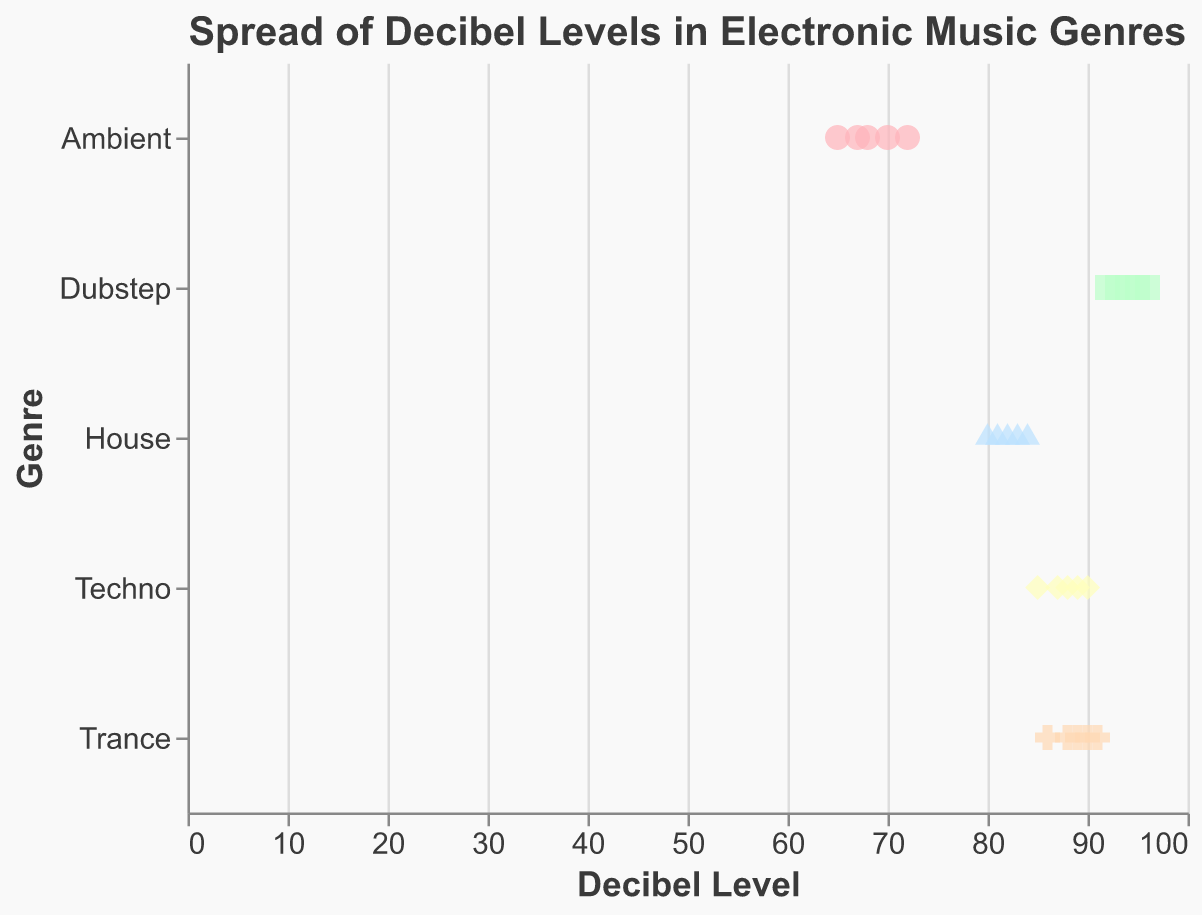What is the genre with the lowest decibel level in the chart? The lowest decibel level shown in the ambient genre is 65. The other genres have higher minimum decibel levels.
Answer: Ambient How many total data points are plotted in the chart? By counting each data point for each genre (Ambient has 5, Techno has 5, House has 5, Trance has 5, Dubstep has 5), we get a total of 25 data points.
Answer: 25 Which genre has the highest decibel level, and what is that level? The highest decibel level is found in the Dubstep genre, with a maximum value of 96.
Answer: Dubstep, 96 What is the range of decibel levels for the House genre? The House genre has decibel levels ranging from 80 to 84. Thus, the range is calculated as 84 - 80 = 4.
Answer: 4 What shapes are used to represent different genres on the plot? The plot uses different shapes to represent genres: circle, square, triangle, diamond, and cross.
Answer: circle, square, triangle, diamond, cross What is the average decibel level of the Techno genre? Sum the decibel levels for Techno (85 + 88 + 90 + 87 + 89) which equals 439. Then, divide by the number of data points (5), so 439 / 5 = 87.8.
Answer: 87.8 How do the average decibel levels of Trance and Dubstep compare? First, calculate the averages: Trance (86 + 89 + 91 + 88 + 90) = 444 / 5 = 88.8, Dubstep (92 + 95 + 93 + 96 + 94) = 470 / 5 = 94. The average for Dubstep (94) is higher than for Trance (88.8).
Answer: Dubstep has a higher average decibel level Which genre has the narrowest spread of decibel levels? By examining the range for each genre: Ambient (72 - 65 = 7), Techno (90 - 85 = 5), House (84 - 80 = 4), Trance (91 - 86 = 5), Dubstep (96 - 92 = 4), House and Dubstep both have the narrowest spread (4).
Answer: House, Dubstep 